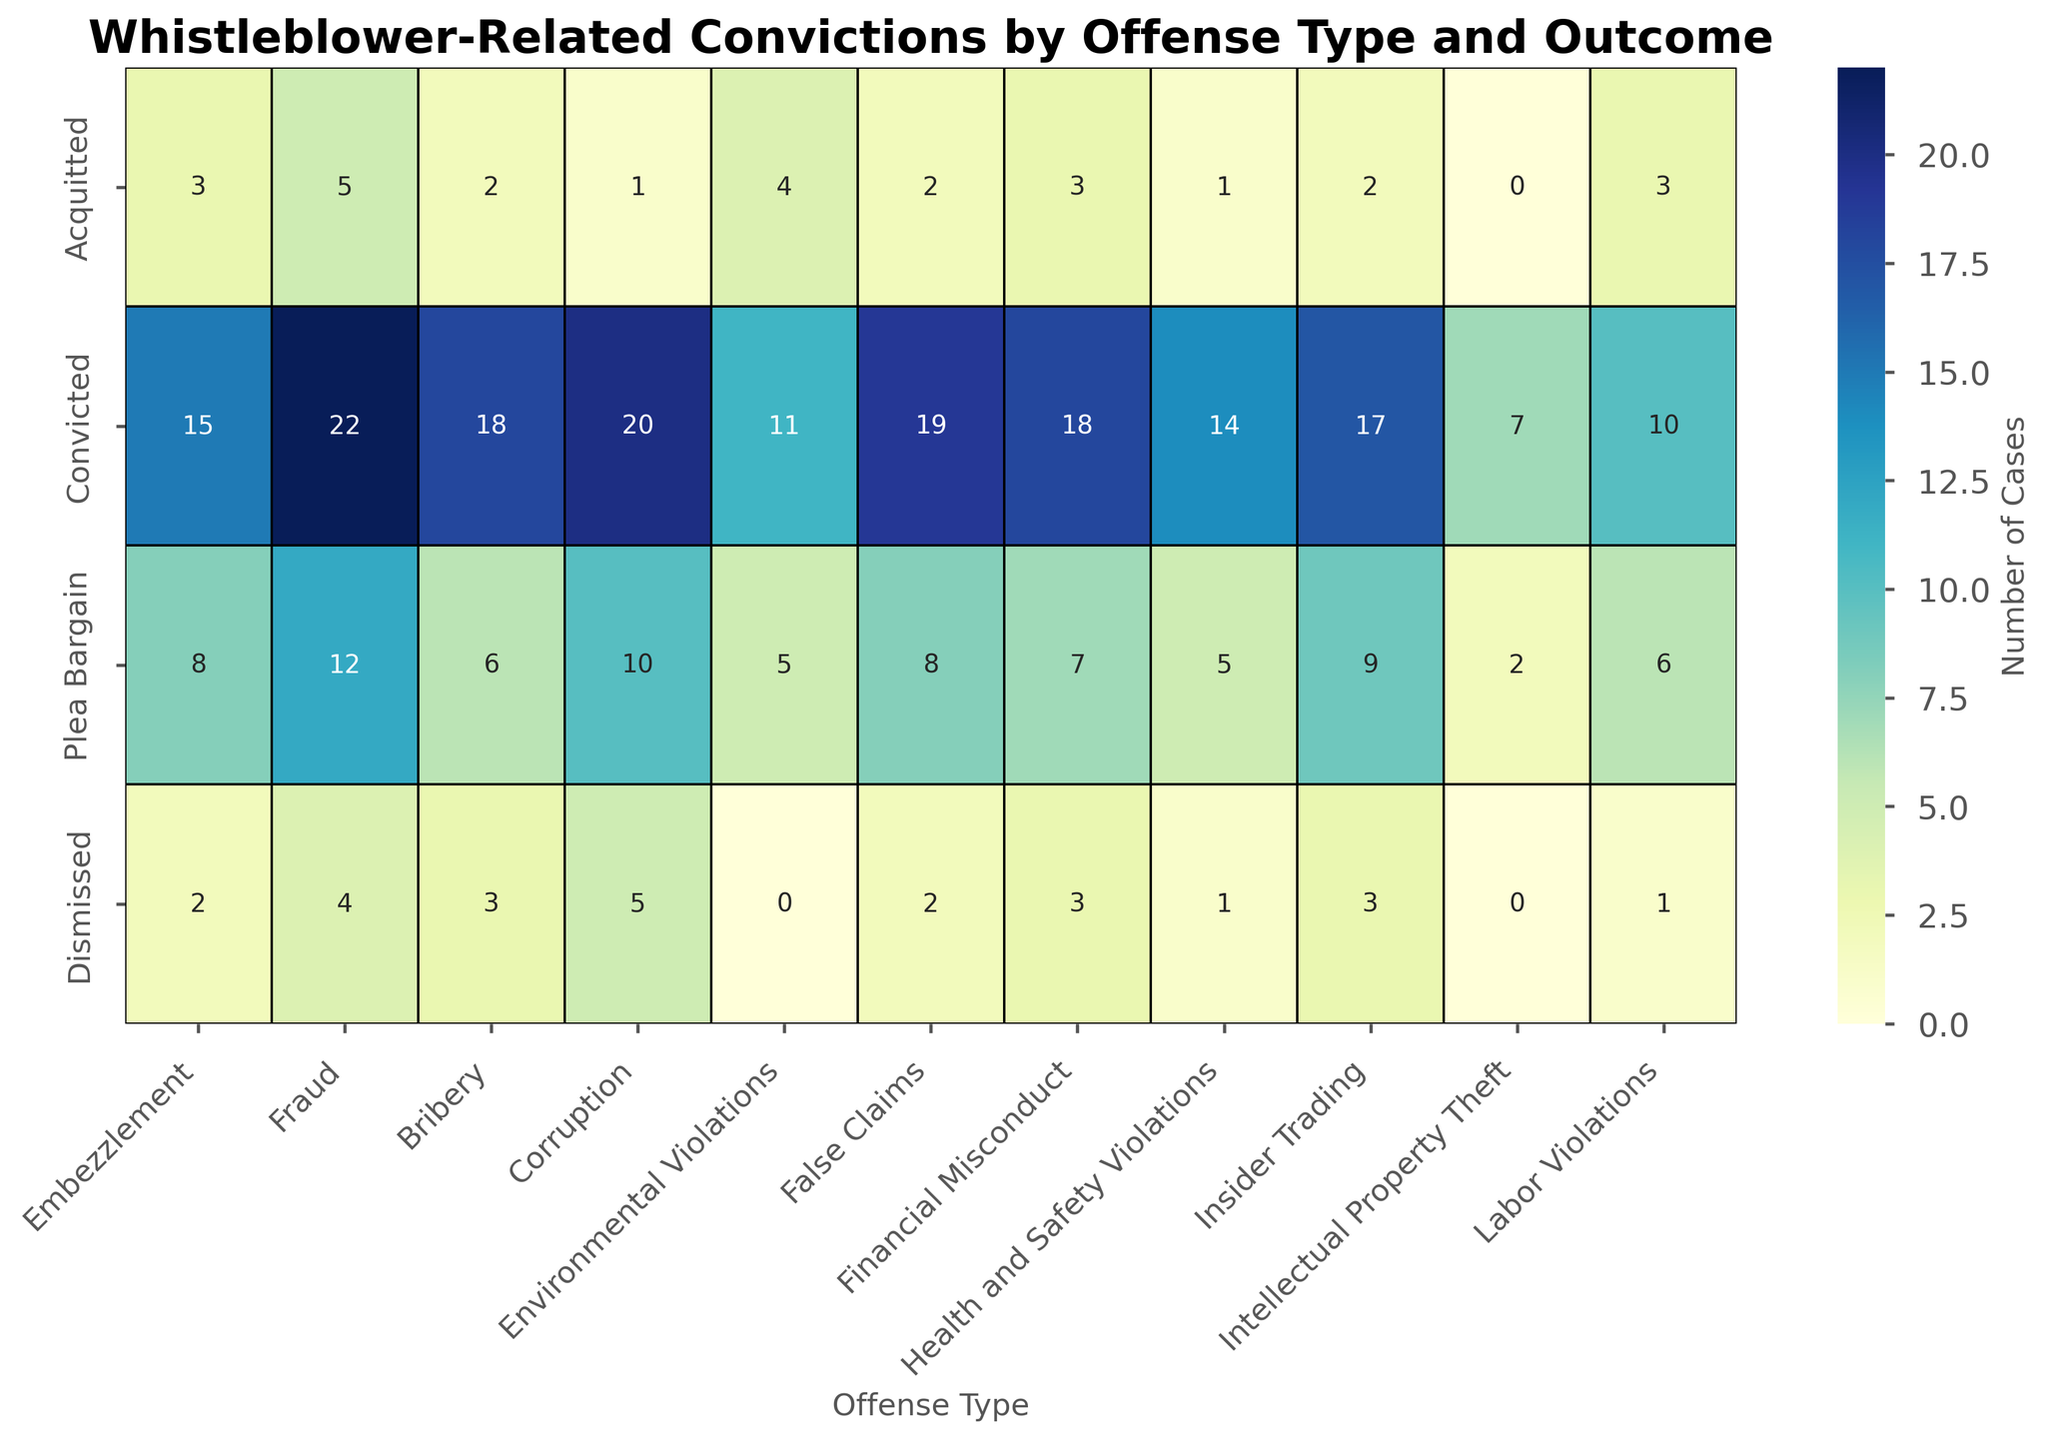Which offense type has the highest number of convictions? Embezzlement has 15, Fraud has 22, Bribery has 18, Corruption has 20, Environmental Violations have 11, False Claims have 19, Financial Misconduct has 18, Health and Safety Violations have 14, Insider Trading has 17, Intellectual Property Theft has 7, and Labor Violations have 10. Fraud has the highest number of convictions.
Answer: Fraud Which outcome has the fewest number of cases across all offense types? Acquitted: 3+5+2+1+4+2+3+1+2+0+3 = 26, Convicted: 15+22+18+20+11+19+18+14+17+7+10 = 171, Plea Bargain: 8+12+6+10+5+8+7+5+9+2+6 = 78, Dismissed: 2+4+3+5+0+2+3+1+3+0+1 = 24. The fewest number of cases are in the Dismissed category.
Answer: Dismissed For Fraud, what is the difference between Convictions and Plea Bargains outcomes? Fraud has 22 Convictions and 12 Plea Bargains. The difference is 22 - 12 = 10.
Answer: 10 Which offense type has the least number of Acquittal cases? Embezzlement has 3, Fraud has 5, Bribery has 2, Corruption has 1, Environmental Violations have 4, False Claims have 2, Financial Misconduct has 3, Health and Safety Violations have 1, Insider Trading has 2, Intellectual Property Theft has 0, and Labor Violations have 3. Intellectual Property Theft has the least number of Acquittal cases.
Answer: Intellectual Property Theft How many total cases are there for Bribery? Bribery has 2 Acquitted, 18 Convicted, 6 Plea Bargain, and 3 Dismissed. The total cases are 2 + 18 + 6 + 3 = 29.
Answer: 29 What is the average number of Convictions across all offense types? The total number of Convictions is 171 (sum of all Conviction cases), and there are 11 offense types. The average is 171 / 11 = 15.545.
Answer: 15.55 Which offense type has the most even distribution among all outcomes? By comparing Acquitted, Convicted, Plea Bargain, and Dismissed values for each offense type visually, Environmental Violations appear to have a relatively even distribution: Acquitted (4), Convicted (11), Plea Bargain (5), Dismissed (0). Each category has a similar order of magnitude.
Answer: Environmental Violations 